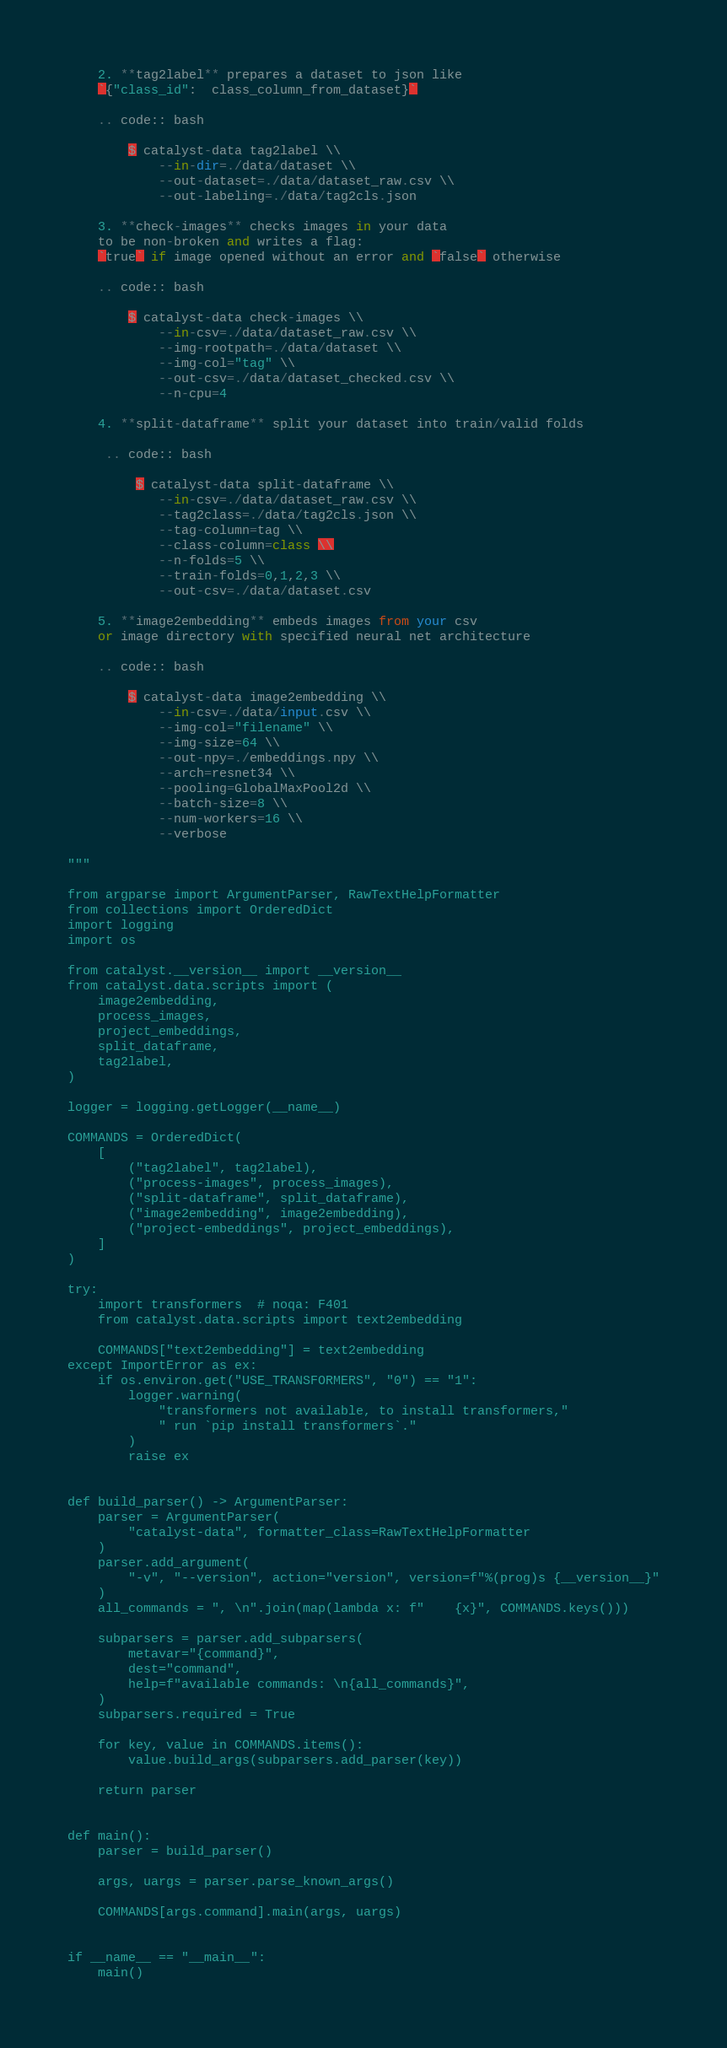Convert code to text. <code><loc_0><loc_0><loc_500><loc_500><_Python_>
    2. **tag2label** prepares a dataset to json like
    `{"class_id":  class_column_from_dataset}`

    .. code:: bash

        $ catalyst-data tag2label \\
            --in-dir=./data/dataset \\
            --out-dataset=./data/dataset_raw.csv \\
            --out-labeling=./data/tag2cls.json

    3. **check-images** checks images in your data
    to be non-broken and writes a flag:
    `true` if image opened without an error and `false` otherwise

    .. code:: bash

        $ catalyst-data check-images \\
            --in-csv=./data/dataset_raw.csv \\
            --img-rootpath=./data/dataset \\
            --img-col="tag" \\
            --out-csv=./data/dataset_checked.csv \\
            --n-cpu=4

    4. **split-dataframe** split your dataset into train/valid folds

     .. code:: bash

         $ catalyst-data split-dataframe \\
            --in-csv=./data/dataset_raw.csv \\
            --tag2class=./data/tag2cls.json \\
            --tag-column=tag \\
            --class-column=class \\
            --n-folds=5 \\
            --train-folds=0,1,2,3 \\
            --out-csv=./data/dataset.csv

    5. **image2embedding** embeds images from your csv
    or image directory with specified neural net architecture

    .. code:: bash

        $ catalyst-data image2embedding \\
            --in-csv=./data/input.csv \\
            --img-col="filename" \\
            --img-size=64 \\
            --out-npy=./embeddings.npy \\
            --arch=resnet34 \\
            --pooling=GlobalMaxPool2d \\
            --batch-size=8 \\
            --num-workers=16 \\
            --verbose

"""

from argparse import ArgumentParser, RawTextHelpFormatter
from collections import OrderedDict
import logging
import os

from catalyst.__version__ import __version__
from catalyst.data.scripts import (
    image2embedding,
    process_images,
    project_embeddings,
    split_dataframe,
    tag2label,
)

logger = logging.getLogger(__name__)

COMMANDS = OrderedDict(
    [
        ("tag2label", tag2label),
        ("process-images", process_images),
        ("split-dataframe", split_dataframe),
        ("image2embedding", image2embedding),
        ("project-embeddings", project_embeddings),
    ]
)

try:
    import transformers  # noqa: F401
    from catalyst.data.scripts import text2embedding

    COMMANDS["text2embedding"] = text2embedding
except ImportError as ex:
    if os.environ.get("USE_TRANSFORMERS", "0") == "1":
        logger.warning(
            "transformers not available, to install transformers,"
            " run `pip install transformers`."
        )
        raise ex


def build_parser() -> ArgumentParser:
    parser = ArgumentParser(
        "catalyst-data", formatter_class=RawTextHelpFormatter
    )
    parser.add_argument(
        "-v", "--version", action="version", version=f"%(prog)s {__version__}"
    )
    all_commands = ", \n".join(map(lambda x: f"    {x}", COMMANDS.keys()))

    subparsers = parser.add_subparsers(
        metavar="{command}",
        dest="command",
        help=f"available commands: \n{all_commands}",
    )
    subparsers.required = True

    for key, value in COMMANDS.items():
        value.build_args(subparsers.add_parser(key))

    return parser


def main():
    parser = build_parser()

    args, uargs = parser.parse_known_args()

    COMMANDS[args.command].main(args, uargs)


if __name__ == "__main__":
    main()
</code> 